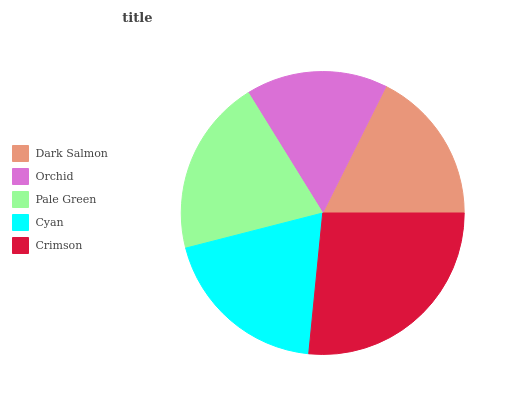Is Orchid the minimum?
Answer yes or no. Yes. Is Crimson the maximum?
Answer yes or no. Yes. Is Pale Green the minimum?
Answer yes or no. No. Is Pale Green the maximum?
Answer yes or no. No. Is Pale Green greater than Orchid?
Answer yes or no. Yes. Is Orchid less than Pale Green?
Answer yes or no. Yes. Is Orchid greater than Pale Green?
Answer yes or no. No. Is Pale Green less than Orchid?
Answer yes or no. No. Is Cyan the high median?
Answer yes or no. Yes. Is Cyan the low median?
Answer yes or no. Yes. Is Pale Green the high median?
Answer yes or no. No. Is Pale Green the low median?
Answer yes or no. No. 